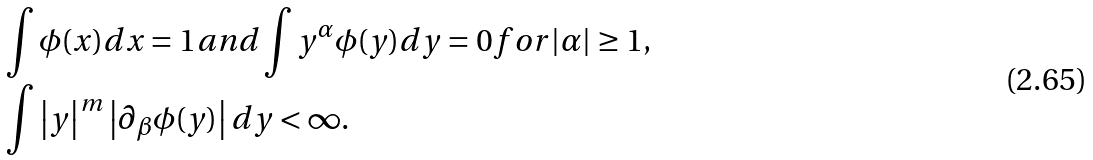<formula> <loc_0><loc_0><loc_500><loc_500>& \int \phi ( x ) d x = 1 a n d \int y ^ { \alpha } \phi ( y ) d y = 0 f o r | \alpha | \geq 1 , \\ & \int \left | y \right | ^ { m } \left | \partial _ { \beta } \phi ( y ) \right | d y < \infty .</formula> 